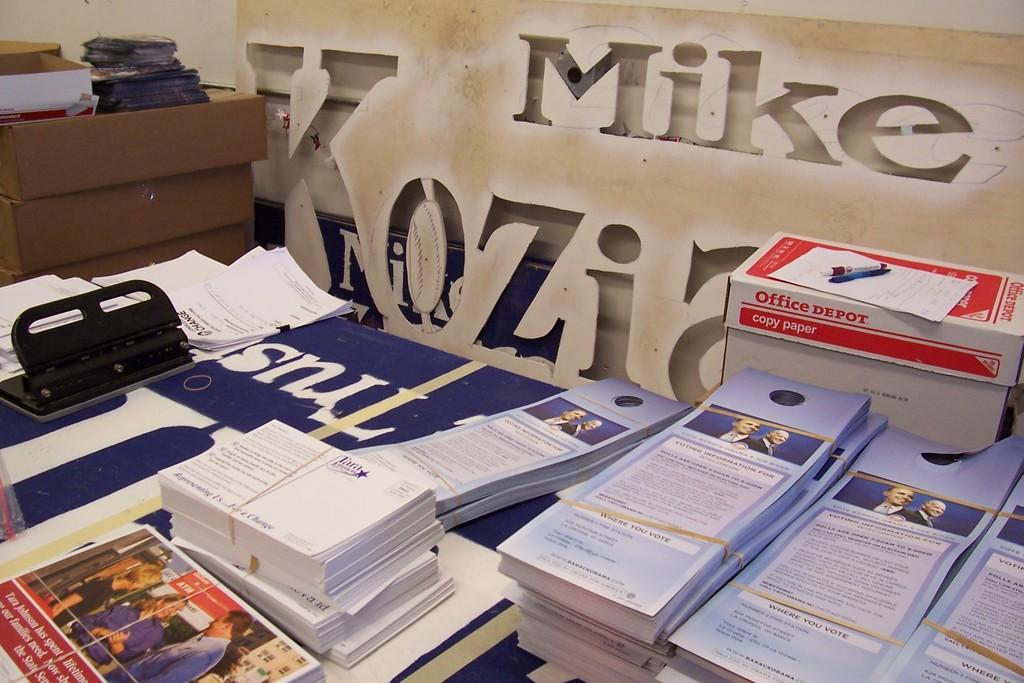<image>
Offer a succinct explanation of the picture presented. Pamphlets sitting inf front of sign that says the name Mike on it. 